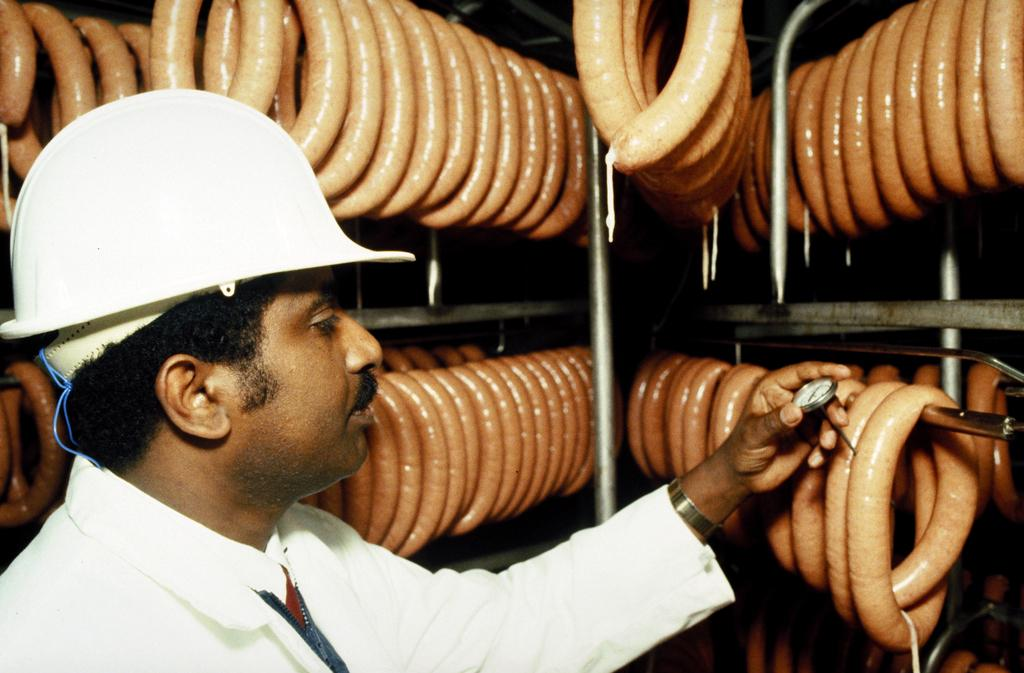What is the main subject of the image? The main subject of the image is a man standing. What is the man wearing on his head? The man is wearing a helmet. What can be seen hanging in the image? There are hot dogs hanged on a metal rod in the image. Where are the trees located in the image? There are no trees present in the image. What does the queen say about the hot dogs in the image? There is no queen present in the image, and therefore no such interaction can be observed. 